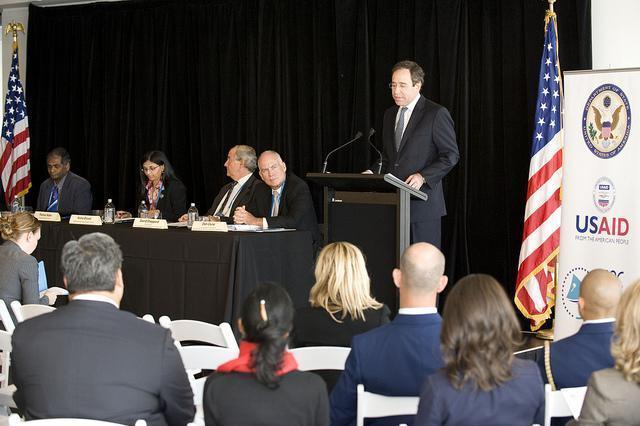How many people are in the picture?
Give a very brief answer. 13. How many blue cars are there?
Give a very brief answer. 0. 